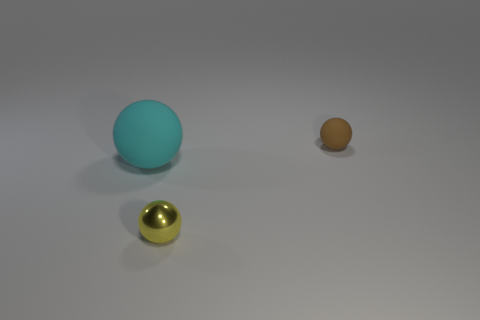What number of objects are either spheres to the right of the large cyan ball or rubber things left of the yellow metal object?
Make the answer very short. 3. Are there fewer tiny yellow things than gray cubes?
Keep it short and to the point. No. What material is the brown thing that is the same size as the yellow sphere?
Give a very brief answer. Rubber. Does the object in front of the large object have the same size as the ball that is behind the cyan matte ball?
Provide a short and direct response. Yes. Is there a red block that has the same material as the brown thing?
Your answer should be very brief. No. How many things are either small shiny spheres that are in front of the small matte object or cyan metal blocks?
Your answer should be compact. 1. Is the small ball that is left of the tiny brown ball made of the same material as the brown thing?
Offer a very short reply. No. Is the shape of the brown matte object the same as the metal thing?
Offer a very short reply. Yes. How many matte objects are on the left side of the tiny object that is in front of the tiny rubber object?
Your answer should be compact. 1. There is another brown object that is the same shape as the large object; what is its material?
Give a very brief answer. Rubber. 